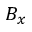Convert formula to latex. <formula><loc_0><loc_0><loc_500><loc_500>B _ { x }</formula> 